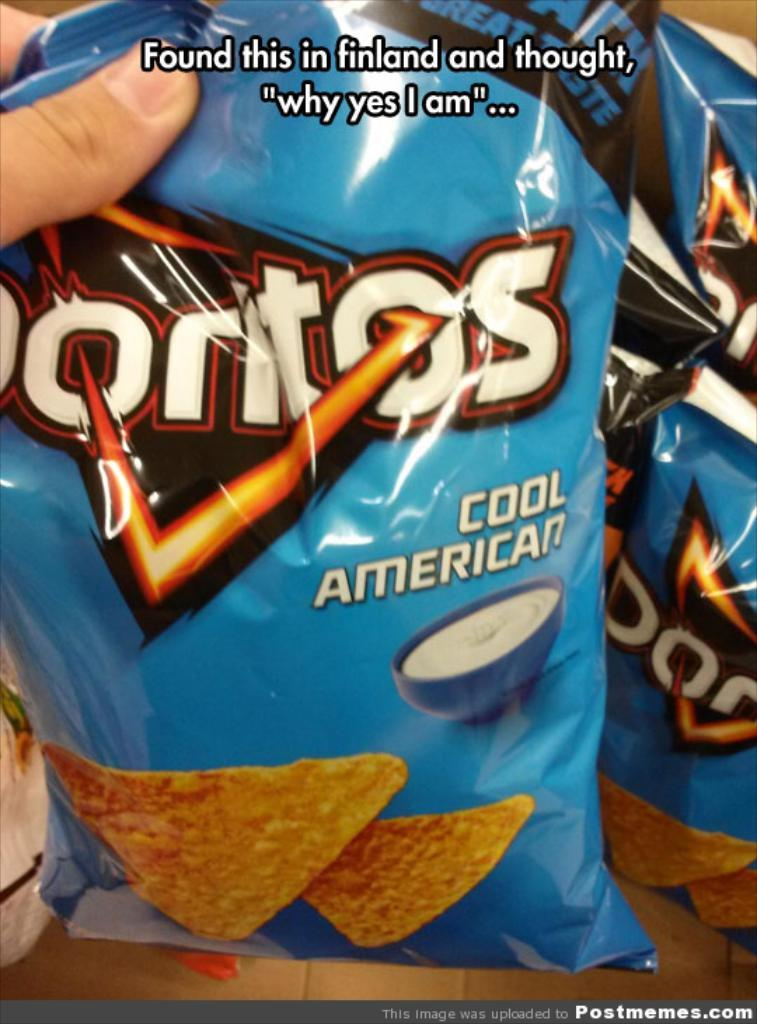What body part is visible in the image? Human fingers are visible in the image. What type of product packaging can be seen in the image? There are blue chips packets in the image. Where is the text located in the image? The text is at the top of the image. What type of wound can be seen on the fingers in the image? There is no wound visible on the fingers in the image. Can you see any animals in the image? No, there are no animals present in the image. 